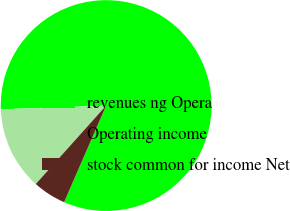<chart> <loc_0><loc_0><loc_500><loc_500><pie_chart><fcel>revenues ng Opera<fcel>Operating income<fcel>stock common for income Net<nl><fcel>82.09%<fcel>12.8%<fcel>5.1%<nl></chart> 